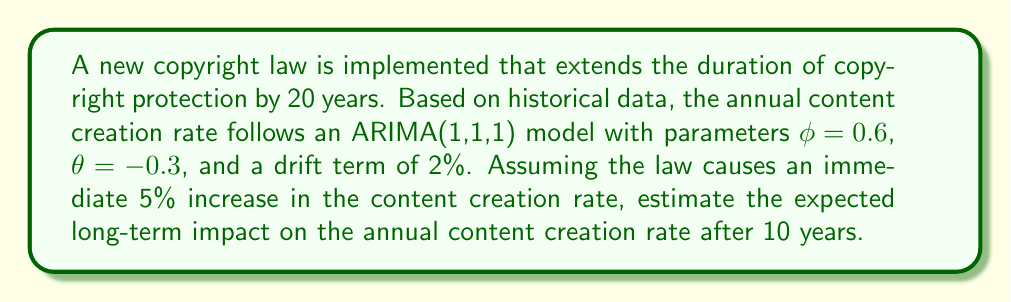Help me with this question. To solve this problem, we need to follow these steps:

1. Understand the ARIMA(1,1,1) model:
   The general form of an ARIMA(1,1,1) model with drift is:
   $$(1-\phi B)(1-B)Y_t = \mu + (1+\theta B)\epsilon_t$$
   where $B$ is the backshift operator, $\phi$ is the AR parameter, $\theta$ is the MA parameter, $\mu$ is the drift term, and $\epsilon_t$ is white noise.

2. Calculate the long-run impact of a shock in an ARIMA(1,1,1) model:
   The long-run impact multiplier for an ARIMA(1,1,1) model is given by:
   $$\psi_{\infty} = \frac{1+\theta}{1-\phi}$$

3. Calculate the immediate impact of the law:
   The law causes an immediate 5% increase in the content creation rate.

4. Calculate the long-term impact:
   Long-term impact = Immediate impact × Long-run impact multiplier
   $$\text{Long-term impact} = 0.05 \times \frac{1+\theta}{1-\phi} = 0.05 \times \frac{1-0.3}{1-0.6} = 0.05 \times \frac{0.7}{0.4} = 0.0875 = 8.75\%$$

5. Calculate the cumulative impact of the drift term over 10 years:
   Cumulative drift = Annual drift × Number of years
   $$\text{Cumulative drift} = 0.02 \times 10 = 0.2 = 20\%$$

6. Combine the long-term impact of the shock and the cumulative drift:
   Total long-term impact = Long-term impact of shock + Cumulative drift
   $$\text{Total long-term impact} = 8.75\% + 20\% = 28.75\%$$

Therefore, the expected long-term impact on the annual content creation rate after 10 years is an increase of 28.75%.
Answer: The expected long-term impact on the annual content creation rate after 10 years is an increase of 28.75%. 